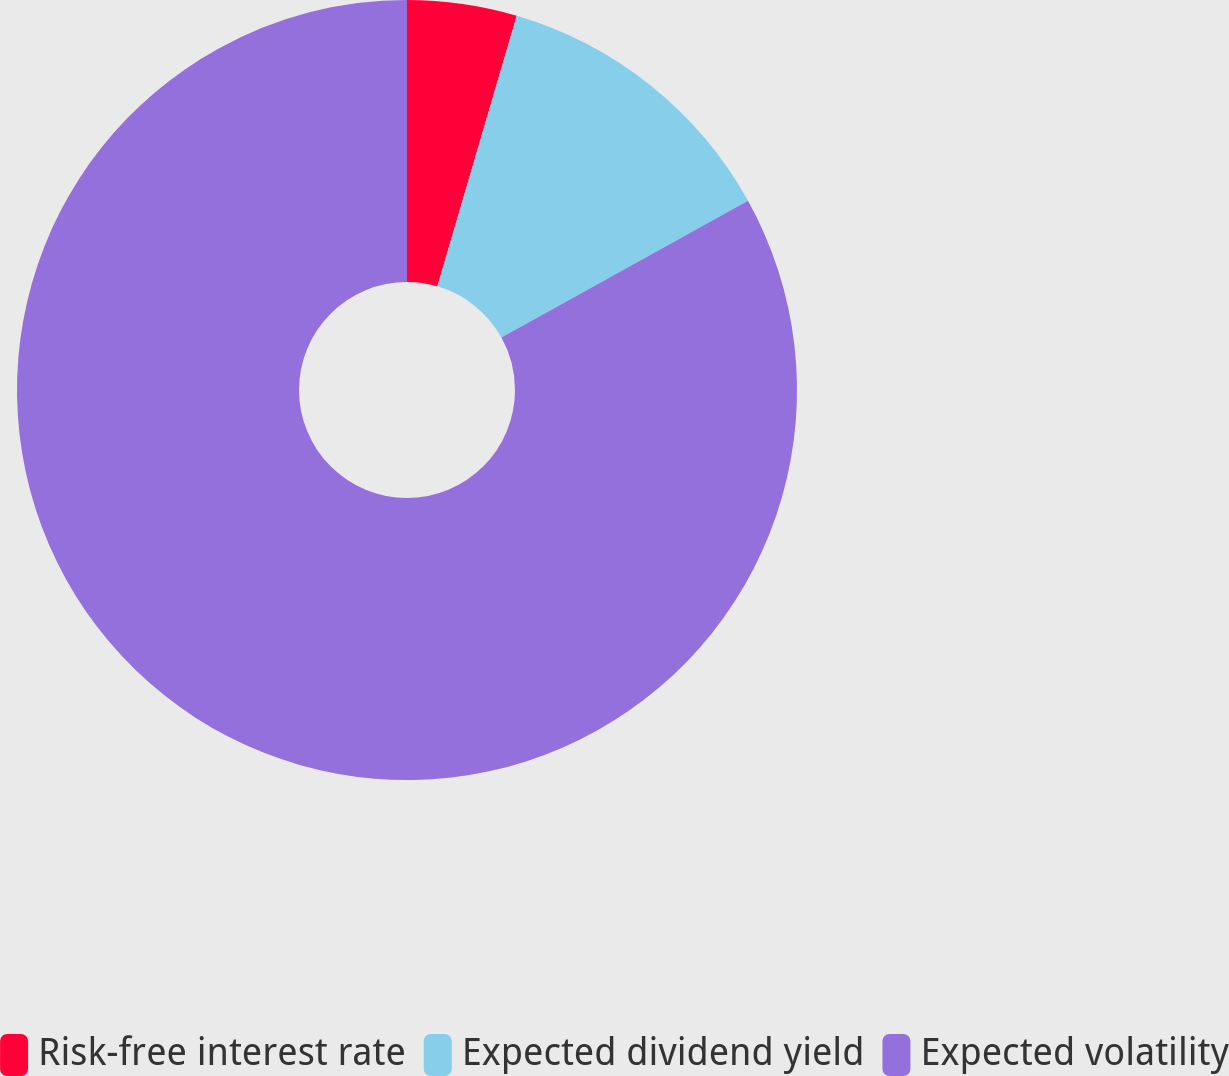Convert chart to OTSL. <chart><loc_0><loc_0><loc_500><loc_500><pie_chart><fcel>Risk-free interest rate<fcel>Expected dividend yield<fcel>Expected volatility<nl><fcel>4.54%<fcel>12.4%<fcel>83.07%<nl></chart> 